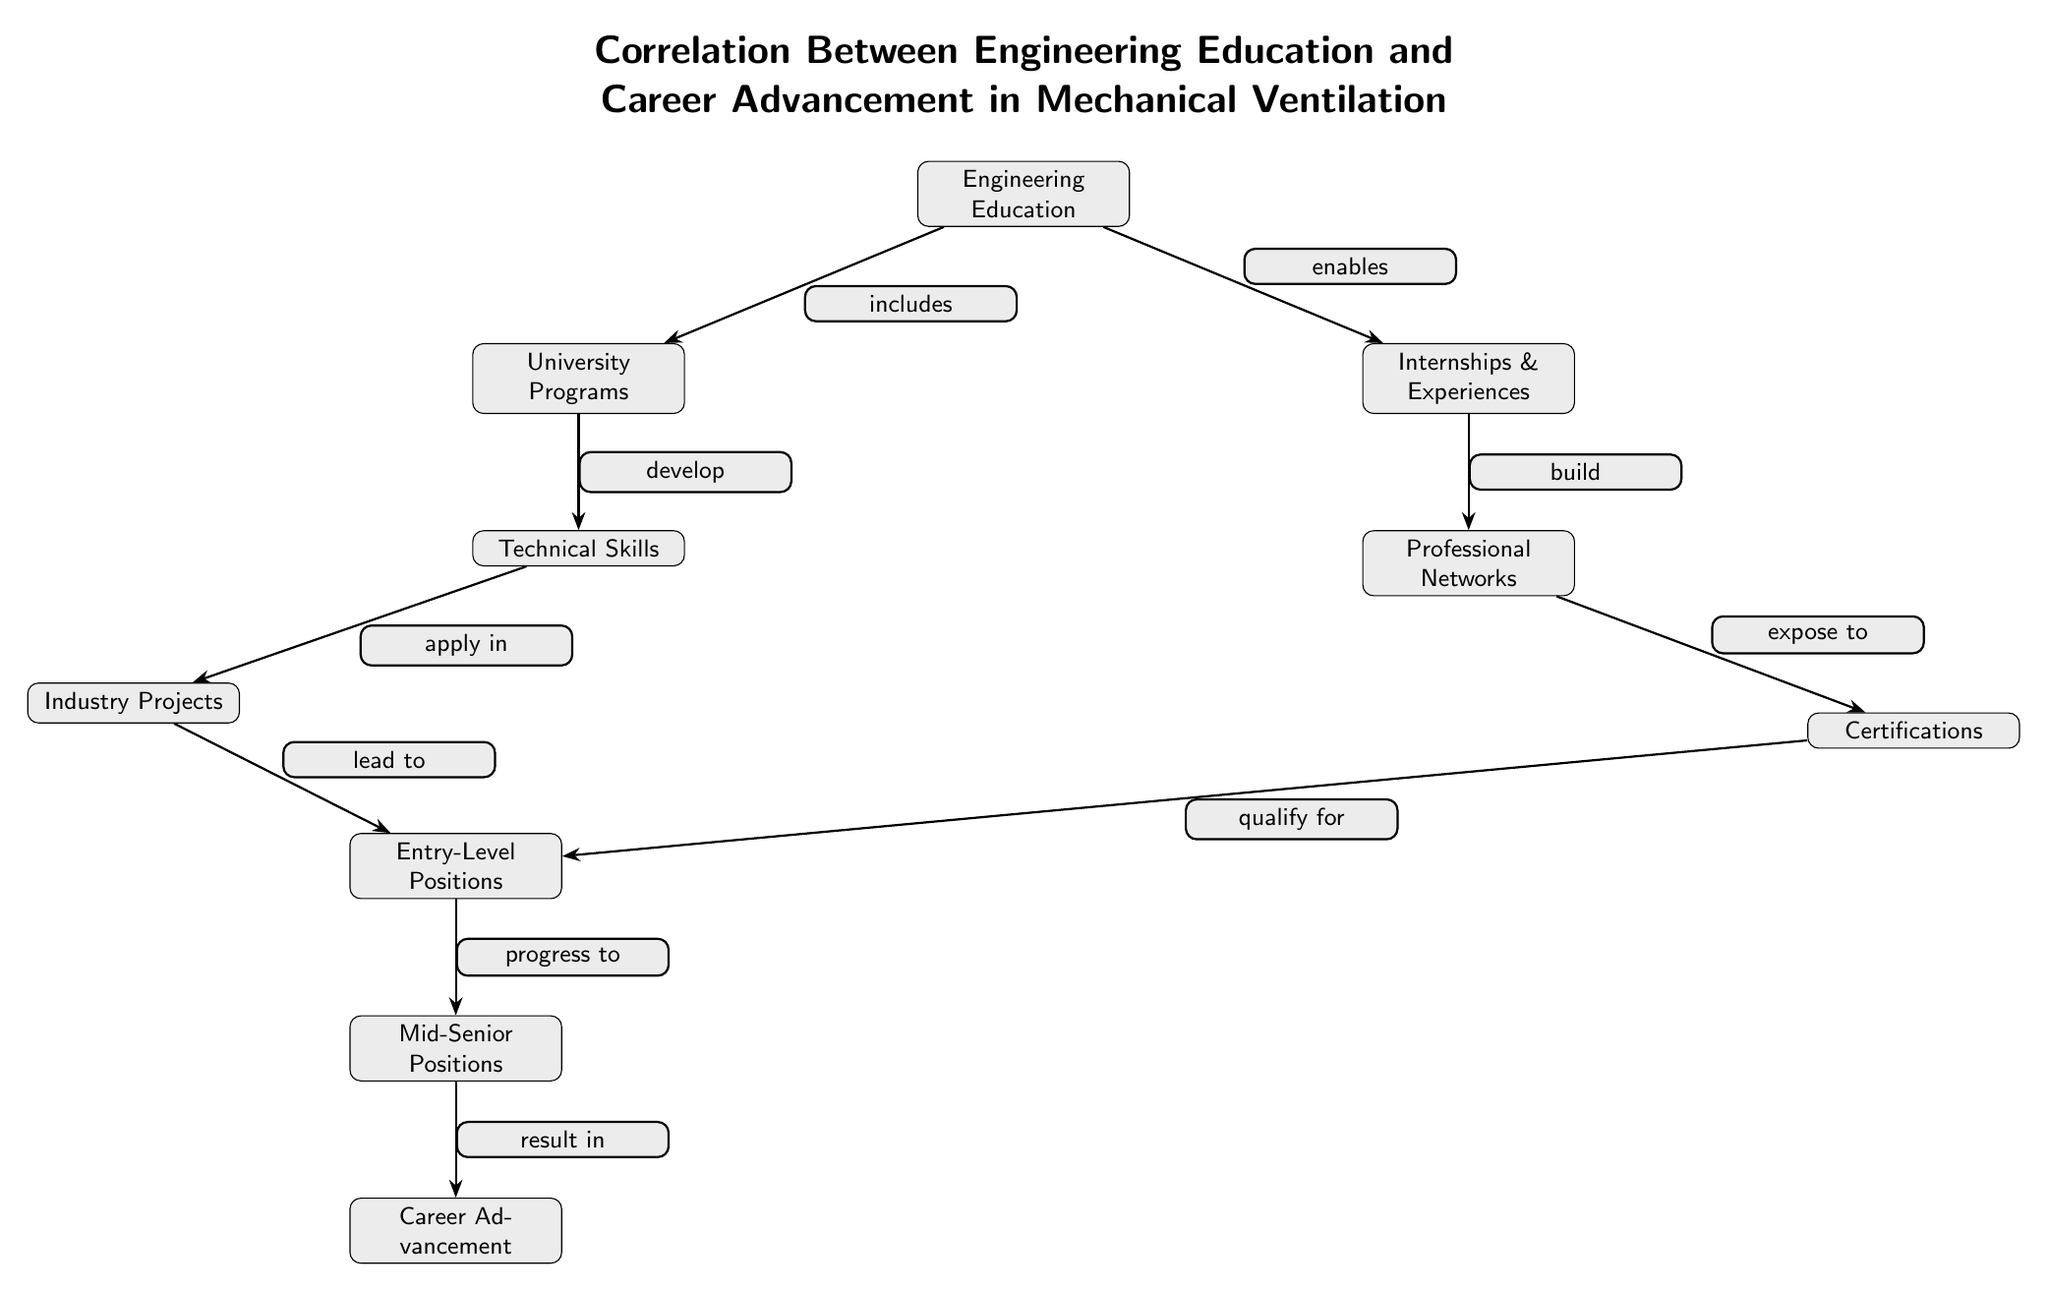What is the initial node in the diagram? The diagram starts with the node labeled "Engineering Education" at the top.
Answer: Engineering Education How many nodes are in the diagram? By counting each individual node represented in the diagram, we find there are ten distinct nodes.
Answer: Ten What relationship does "University Programs" have with "Engineering Education"? The diagram shows that "University Programs" is included under "Engineering Education," indicating it is a part of that broader category.
Answer: includes What leads to "Entry-Level Positions"? According to the diagram, both "Certifications" and "Industry Projects" lead to "Entry-Level Positions," establishing a pathway to that node.
Answer: Certifications, Industry Projects Which step directly follows "Mid-Senior Positions"? The next step that follows "Mid-Senior Positions" in the career advancement flow is "Career Advancement."
Answer: Career Advancement What is one outcome derived from "Technical Skills"? The diagram indicates that "Technical Skills" applies in the context of "Industry Projects," suggesting it leads to practical experience in the field.
Answer: Industry Projects Identify one node that is influenced by "Internships & Experiences." The diagram shows that "Internships & Experiences" builds "Professional Networks," indicating that the latter relies on the former for development.
Answer: Professional Networks How does "Career Advancement" relate to "Mid-Senior Positions"? The relationship depicted shows that "Mid-Senior Positions" progress to "Career Advancement," indicating a sequential step in career growth.
Answer: progress to What type of relationship exists between "Professional Networks" and "Certifications"? The relationship shows that "Professional Networks" exposes individuals to "Certifications," signifying a supportive role in acquiring them.
Answer: expose to 